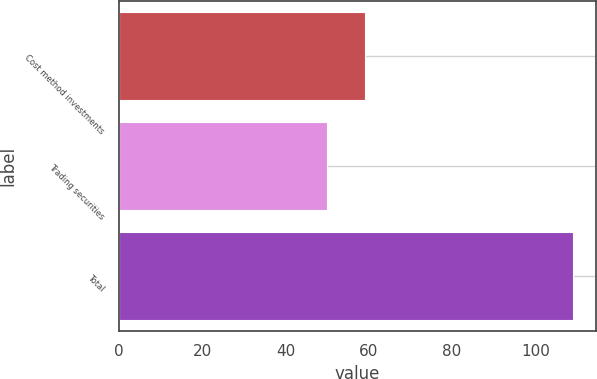<chart> <loc_0><loc_0><loc_500><loc_500><bar_chart><fcel>Cost method investments<fcel>Trading securities<fcel>Total<nl><fcel>59<fcel>50<fcel>109<nl></chart> 